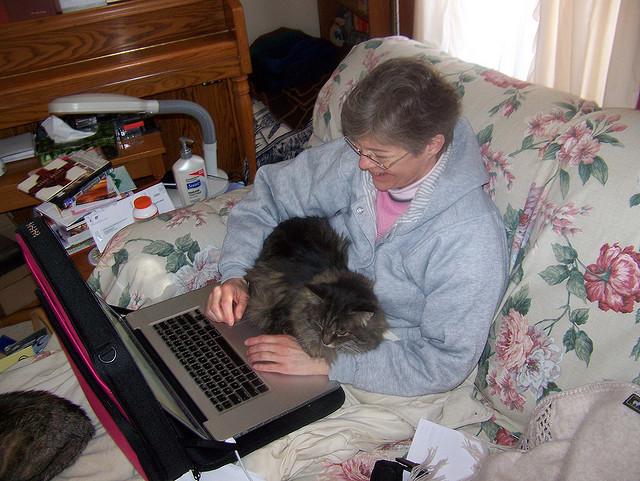What might this person be preparing for?
Be succinct. Facetime. What kind of print is on the couch?
Keep it brief. Floral. Is the woman happy to have the cat on her lap?
Give a very brief answer. Yes. Is the table beside the woman neat?
Short answer required. No. 